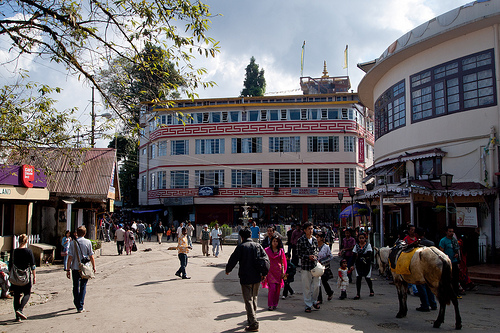<image>
Is there a man to the left of the woman? Yes. From this viewpoint, the man is positioned to the left side relative to the woman. 